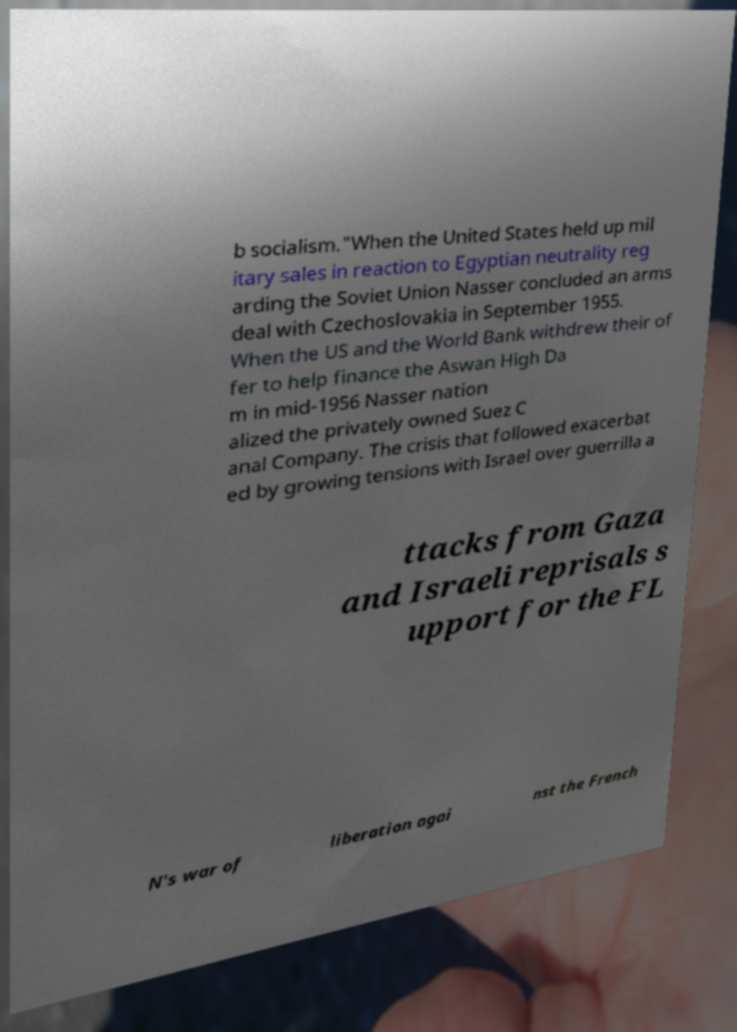Please identify and transcribe the text found in this image. b socialism."When the United States held up mil itary sales in reaction to Egyptian neutrality reg arding the Soviet Union Nasser concluded an arms deal with Czechoslovakia in September 1955. When the US and the World Bank withdrew their of fer to help finance the Aswan High Da m in mid-1956 Nasser nation alized the privately owned Suez C anal Company. The crisis that followed exacerbat ed by growing tensions with Israel over guerrilla a ttacks from Gaza and Israeli reprisals s upport for the FL N's war of liberation agai nst the French 